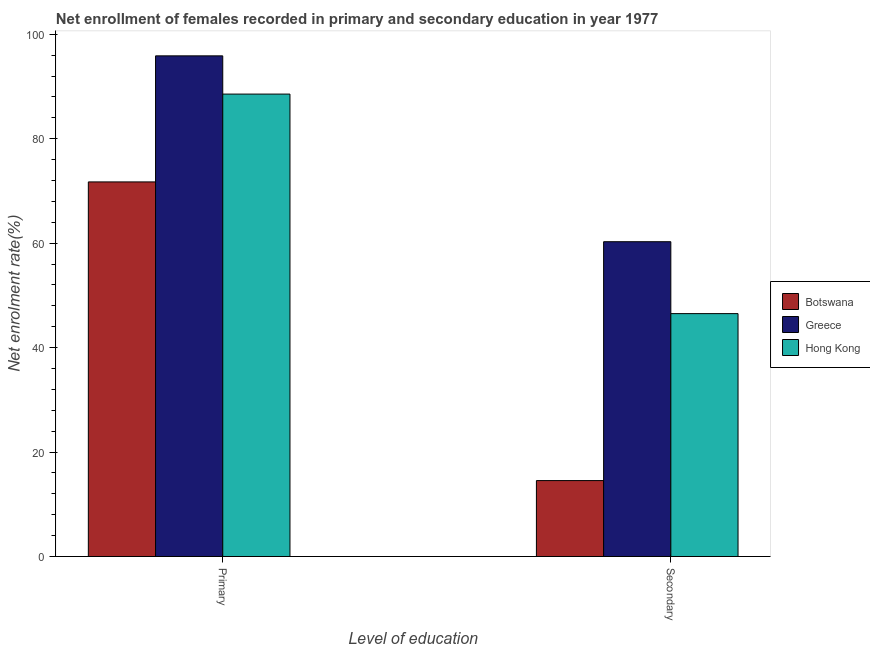Are the number of bars per tick equal to the number of legend labels?
Your response must be concise. Yes. How many bars are there on the 1st tick from the left?
Your answer should be compact. 3. How many bars are there on the 1st tick from the right?
Offer a very short reply. 3. What is the label of the 1st group of bars from the left?
Give a very brief answer. Primary. What is the enrollment rate in secondary education in Hong Kong?
Keep it short and to the point. 46.51. Across all countries, what is the maximum enrollment rate in secondary education?
Your answer should be very brief. 60.28. Across all countries, what is the minimum enrollment rate in secondary education?
Keep it short and to the point. 14.54. In which country was the enrollment rate in primary education maximum?
Keep it short and to the point. Greece. In which country was the enrollment rate in secondary education minimum?
Your response must be concise. Botswana. What is the total enrollment rate in secondary education in the graph?
Your response must be concise. 121.33. What is the difference between the enrollment rate in primary education in Botswana and that in Greece?
Offer a terse response. -24.13. What is the difference between the enrollment rate in primary education in Hong Kong and the enrollment rate in secondary education in Botswana?
Your answer should be compact. 74. What is the average enrollment rate in secondary education per country?
Offer a very short reply. 40.44. What is the difference between the enrollment rate in secondary education and enrollment rate in primary education in Greece?
Ensure brevity in your answer.  -35.58. What is the ratio of the enrollment rate in primary education in Hong Kong to that in Greece?
Provide a short and direct response. 0.92. Is the enrollment rate in secondary education in Hong Kong less than that in Botswana?
Ensure brevity in your answer.  No. What does the 1st bar from the left in Primary represents?
Ensure brevity in your answer.  Botswana. What does the 2nd bar from the right in Secondary represents?
Make the answer very short. Greece. Are all the bars in the graph horizontal?
Your response must be concise. No. What is the difference between two consecutive major ticks on the Y-axis?
Make the answer very short. 20. Does the graph contain grids?
Your response must be concise. No. Where does the legend appear in the graph?
Give a very brief answer. Center right. How many legend labels are there?
Your answer should be very brief. 3. How are the legend labels stacked?
Offer a very short reply. Vertical. What is the title of the graph?
Offer a very short reply. Net enrollment of females recorded in primary and secondary education in year 1977. What is the label or title of the X-axis?
Provide a succinct answer. Level of education. What is the label or title of the Y-axis?
Make the answer very short. Net enrolment rate(%). What is the Net enrolment rate(%) in Botswana in Primary?
Provide a short and direct response. 71.73. What is the Net enrolment rate(%) in Greece in Primary?
Make the answer very short. 95.86. What is the Net enrolment rate(%) in Hong Kong in Primary?
Your answer should be compact. 88.54. What is the Net enrolment rate(%) of Botswana in Secondary?
Offer a very short reply. 14.54. What is the Net enrolment rate(%) in Greece in Secondary?
Give a very brief answer. 60.28. What is the Net enrolment rate(%) in Hong Kong in Secondary?
Your answer should be very brief. 46.51. Across all Level of education, what is the maximum Net enrolment rate(%) of Botswana?
Offer a terse response. 71.73. Across all Level of education, what is the maximum Net enrolment rate(%) of Greece?
Offer a terse response. 95.86. Across all Level of education, what is the maximum Net enrolment rate(%) in Hong Kong?
Offer a terse response. 88.54. Across all Level of education, what is the minimum Net enrolment rate(%) in Botswana?
Your answer should be very brief. 14.54. Across all Level of education, what is the minimum Net enrolment rate(%) of Greece?
Make the answer very short. 60.28. Across all Level of education, what is the minimum Net enrolment rate(%) in Hong Kong?
Your response must be concise. 46.51. What is the total Net enrolment rate(%) of Botswana in the graph?
Provide a short and direct response. 86.27. What is the total Net enrolment rate(%) in Greece in the graph?
Make the answer very short. 156.14. What is the total Net enrolment rate(%) of Hong Kong in the graph?
Make the answer very short. 135.05. What is the difference between the Net enrolment rate(%) of Botswana in Primary and that in Secondary?
Your answer should be compact. 57.19. What is the difference between the Net enrolment rate(%) in Greece in Primary and that in Secondary?
Offer a very short reply. 35.58. What is the difference between the Net enrolment rate(%) of Hong Kong in Primary and that in Secondary?
Provide a succinct answer. 42.03. What is the difference between the Net enrolment rate(%) of Botswana in Primary and the Net enrolment rate(%) of Greece in Secondary?
Provide a succinct answer. 11.45. What is the difference between the Net enrolment rate(%) of Botswana in Primary and the Net enrolment rate(%) of Hong Kong in Secondary?
Keep it short and to the point. 25.22. What is the difference between the Net enrolment rate(%) in Greece in Primary and the Net enrolment rate(%) in Hong Kong in Secondary?
Offer a terse response. 49.35. What is the average Net enrolment rate(%) in Botswana per Level of education?
Your answer should be very brief. 43.13. What is the average Net enrolment rate(%) of Greece per Level of education?
Keep it short and to the point. 78.07. What is the average Net enrolment rate(%) of Hong Kong per Level of education?
Your answer should be very brief. 67.52. What is the difference between the Net enrolment rate(%) in Botswana and Net enrolment rate(%) in Greece in Primary?
Your answer should be compact. -24.13. What is the difference between the Net enrolment rate(%) of Botswana and Net enrolment rate(%) of Hong Kong in Primary?
Your response must be concise. -16.81. What is the difference between the Net enrolment rate(%) of Greece and Net enrolment rate(%) of Hong Kong in Primary?
Make the answer very short. 7.32. What is the difference between the Net enrolment rate(%) of Botswana and Net enrolment rate(%) of Greece in Secondary?
Offer a terse response. -45.74. What is the difference between the Net enrolment rate(%) in Botswana and Net enrolment rate(%) in Hong Kong in Secondary?
Give a very brief answer. -31.97. What is the difference between the Net enrolment rate(%) in Greece and Net enrolment rate(%) in Hong Kong in Secondary?
Provide a short and direct response. 13.77. What is the ratio of the Net enrolment rate(%) of Botswana in Primary to that in Secondary?
Your answer should be very brief. 4.93. What is the ratio of the Net enrolment rate(%) in Greece in Primary to that in Secondary?
Your answer should be compact. 1.59. What is the ratio of the Net enrolment rate(%) of Hong Kong in Primary to that in Secondary?
Your answer should be very brief. 1.9. What is the difference between the highest and the second highest Net enrolment rate(%) of Botswana?
Your answer should be compact. 57.19. What is the difference between the highest and the second highest Net enrolment rate(%) of Greece?
Your answer should be compact. 35.58. What is the difference between the highest and the second highest Net enrolment rate(%) in Hong Kong?
Offer a very short reply. 42.03. What is the difference between the highest and the lowest Net enrolment rate(%) in Botswana?
Your answer should be very brief. 57.19. What is the difference between the highest and the lowest Net enrolment rate(%) in Greece?
Your answer should be very brief. 35.58. What is the difference between the highest and the lowest Net enrolment rate(%) of Hong Kong?
Offer a very short reply. 42.03. 